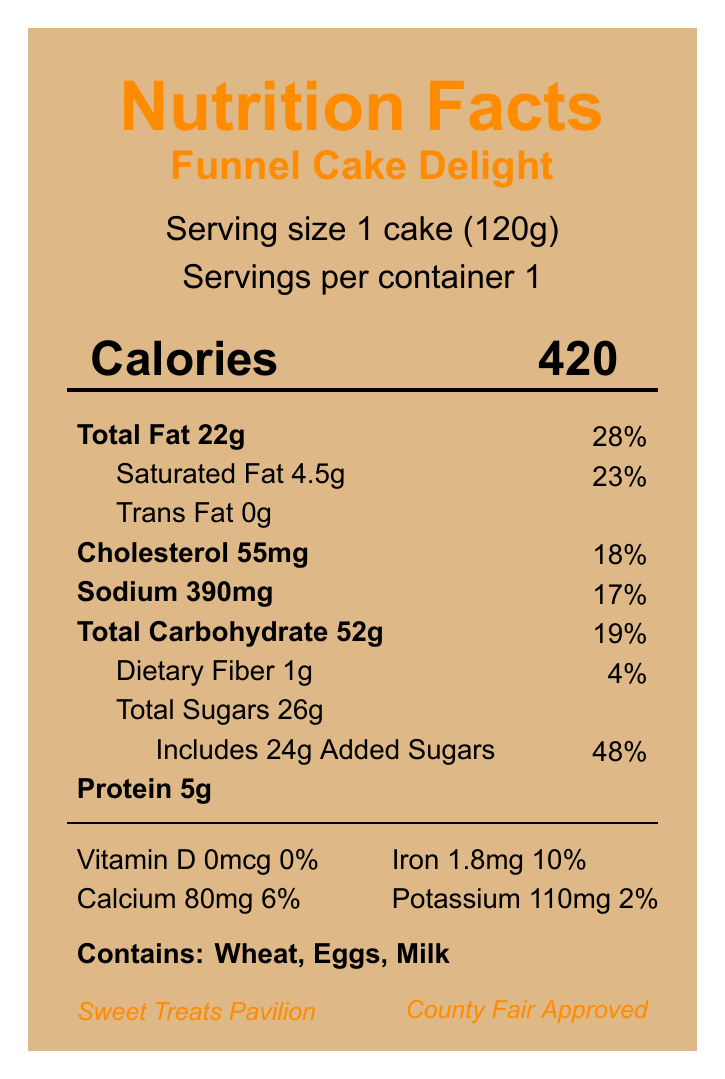what is the serving size for Funnel Cake Delight? The serving size is explicitly mentioned as "1 cake (120g)" under the serving information.
Answer: 1 cake (120g) how many calories does one serving of Funnel Cake Delight contain? The calories section indicates that one serving contains 420 calories.
Answer: 420 what is the total fat content and its daily value percentage in Funnel Cake Delight? The total fat content is listed as 22g, and the daily value percentage is 28%.
Answer: 22g, 28% what allergens are present in Funnel Cake Delight? The document lists the allergens as "Contains: Wheat, Eggs, Milk."
Answer: Wheat, Eggs, Milk which pavilion sells Funnel Cake Delight? Under fairground information, it is mentioned that Funnel Cake Delight is sold at the Sweet Treats Pavilion.
Answer: Sweet Treats Pavilion what is the recommended storage instruction for Funnel Cake Delight? A. Refrigerate after opening B. Freeze and serve later C. Serve fresh D. Store in a cool, dry place The storage instructions indicate "Serve fresh. Not suitable for storage."
Answer: C how much dietary fiber is in one serving of Funnel Cake Delight? A. 0g B. 1g C. 2g D. 3g According to the nutrient information, the dietary fiber content is 1g.
Answer: B how much sodium does one serving of Funnel Cake Delight have? The sodium content for one serving is listed as 390mg in the document.
Answer: 390mg is Funnel Cake Delight deep-fried? The preparation method states that Funnel Cake Delight is "Deep-fried."
Answer: Yes does Funnel Cake Delight meet county fair food safety regulations? It is mentioned under event compliance that the item meets County Fair Food Safety Regulations.
Answer: Yes what are two vitamins or minerals and their daily value percentages in Funnel Cake Delight? The document lists calcium with 80mg (6%) and iron with 1.8mg (10%).
Answer: Calcium 6%, Iron 10% provide a summary of the nutrition facts for Funnel Cake Delight. This summary captures the main nutritional elements of the funnel cake, including calories, fat, sugars, vitamins, and allergens.
Answer: Funnel Cake Delight has a serving size of 1 cake (120g). It contains 420 calories, 22g of total fat (28% DV), 4.5g of saturated fat (23% DV), 0g of trans fat, 55mg of cholesterol (18% DV), 390mg of sodium (17% DV), 52g of carbohydrates (19% DV) including 1g of dietary fiber (4% DV) and 26g of total sugars with 24g of added sugars (48% DV). It provides 5g of protein, and very minimal vitamins and minerals except for calcium at 6%, iron at 10%, and potassium at 2%. The product contains wheat, eggs, and milk allergens, and is sold at the Sweet Treats Pavilion. what is the price of Funnel Cake Delight? The document does not provide any information on the price of Funnel Cake Delight.
Answer: Not enough information 